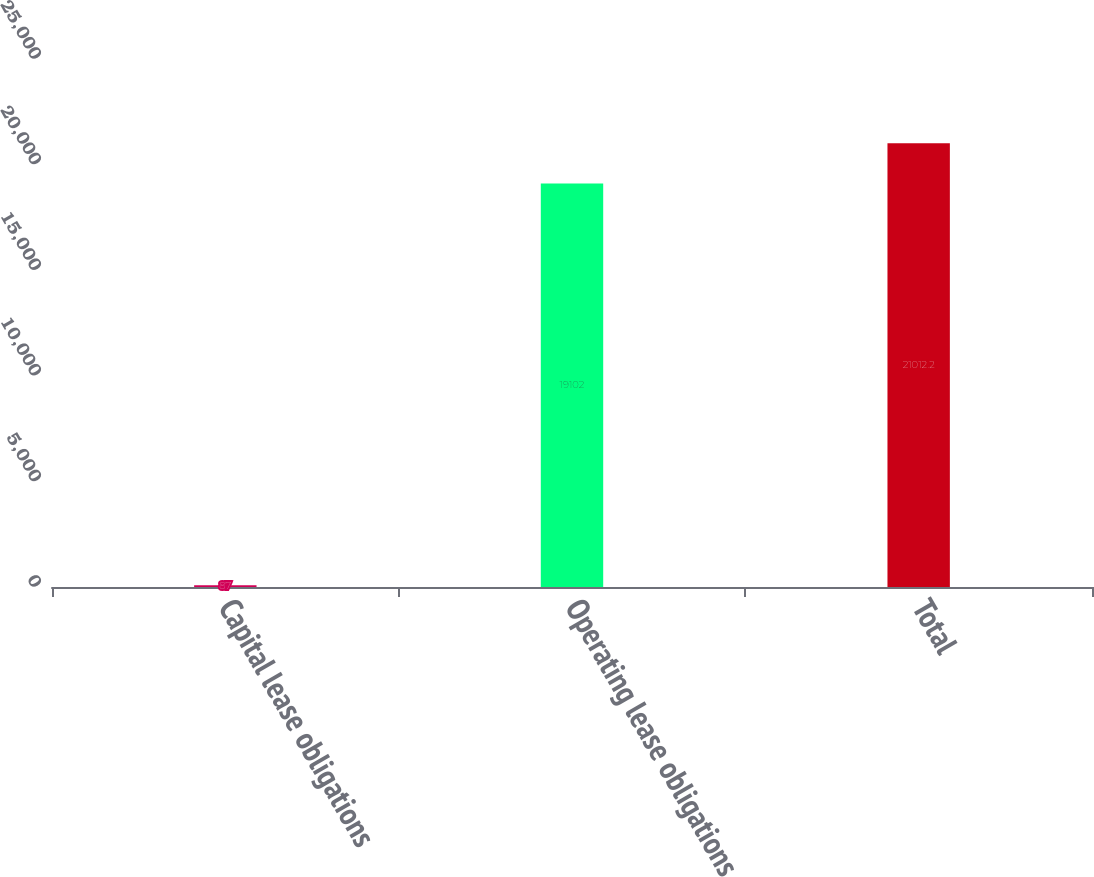<chart> <loc_0><loc_0><loc_500><loc_500><bar_chart><fcel>Capital lease obligations<fcel>Operating lease obligations<fcel>Total<nl><fcel>87<fcel>19102<fcel>21012.2<nl></chart> 